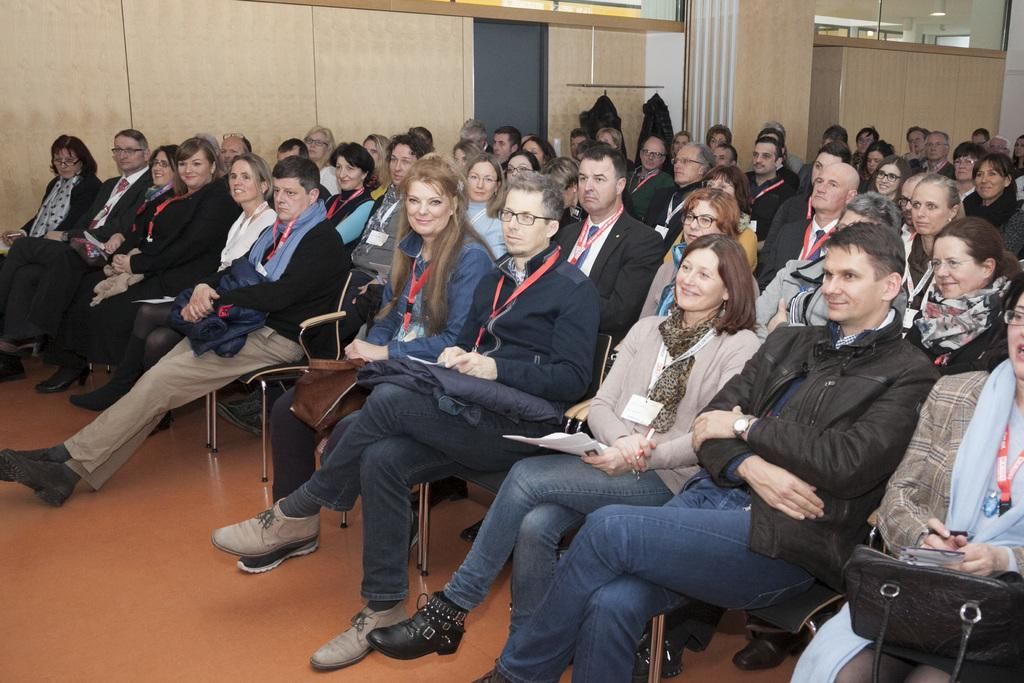What are the people in the image doing? The people in the image are sitting on chairs. What is the surface beneath the people in the image? There is a floor visible in the image. What can be seen in the background of the image? There is a wall, lights, clothes, and a curtain in the background of the image. What type of oven is visible in the image? There is no oven present in the image. 